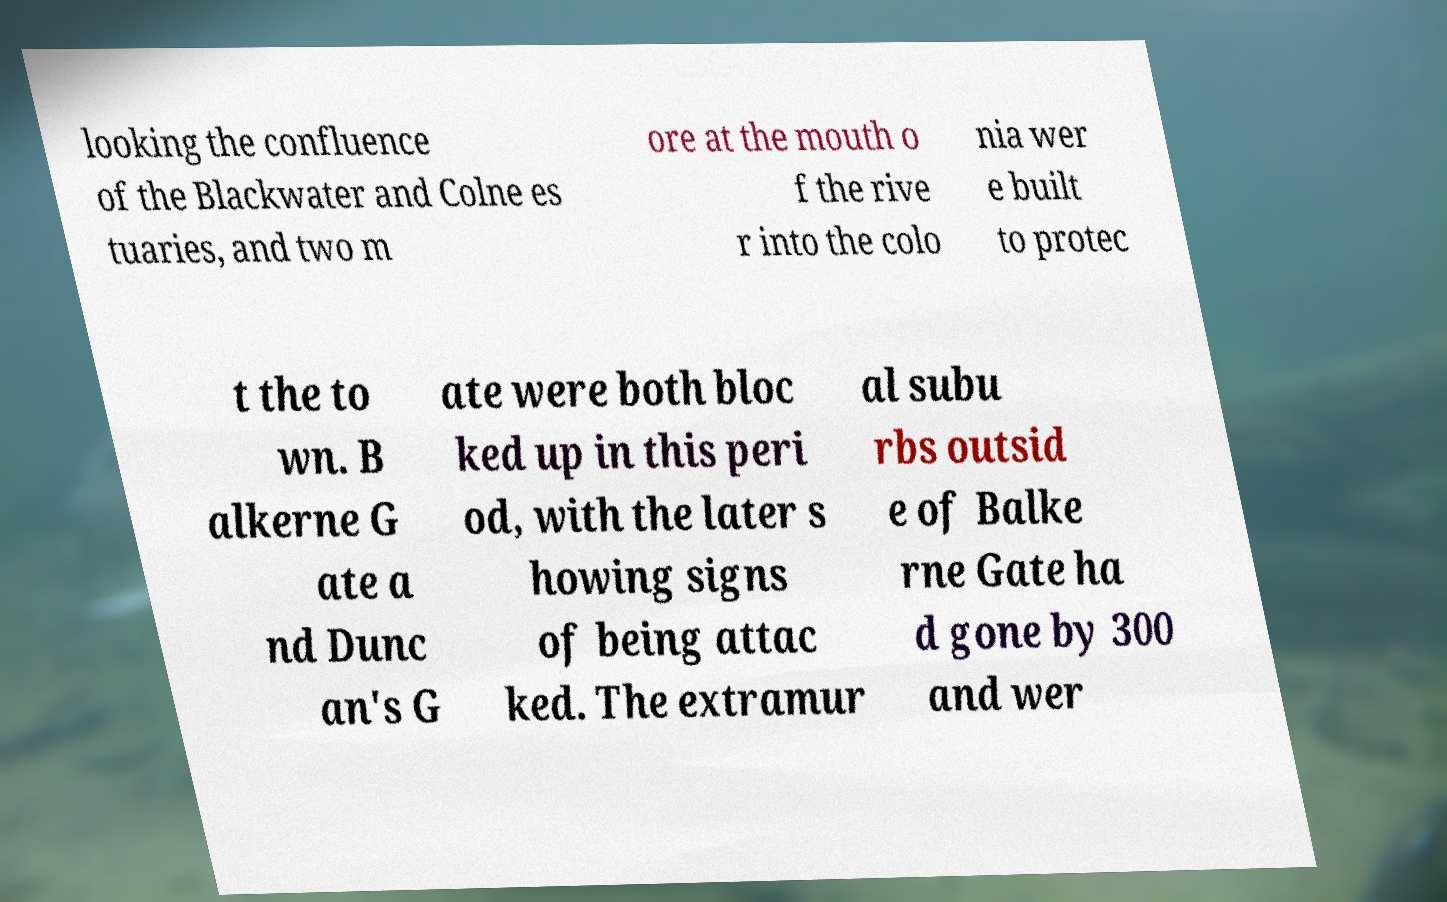Could you assist in decoding the text presented in this image and type it out clearly? looking the confluence of the Blackwater and Colne es tuaries, and two m ore at the mouth o f the rive r into the colo nia wer e built to protec t the to wn. B alkerne G ate a nd Dunc an's G ate were both bloc ked up in this peri od, with the later s howing signs of being attac ked. The extramur al subu rbs outsid e of Balke rne Gate ha d gone by 300 and wer 